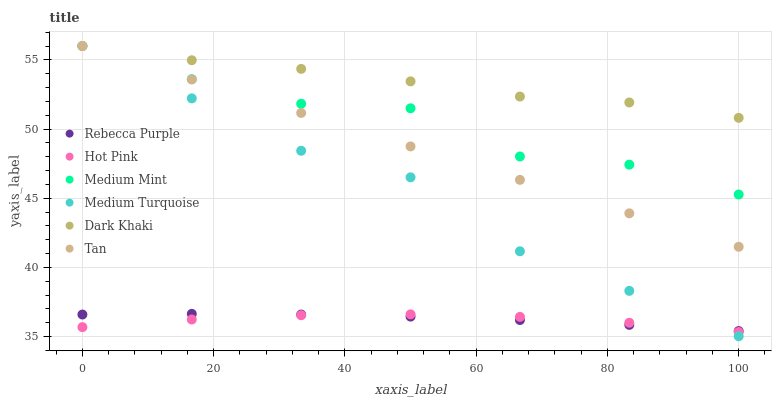Does Hot Pink have the minimum area under the curve?
Answer yes or no. Yes. Does Dark Khaki have the maximum area under the curve?
Answer yes or no. Yes. Does Dark Khaki have the minimum area under the curve?
Answer yes or no. No. Does Hot Pink have the maximum area under the curve?
Answer yes or no. No. Is Tan the smoothest?
Answer yes or no. Yes. Is Medium Mint the roughest?
Answer yes or no. Yes. Is Hot Pink the smoothest?
Answer yes or no. No. Is Hot Pink the roughest?
Answer yes or no. No. Does Medium Turquoise have the lowest value?
Answer yes or no. Yes. Does Hot Pink have the lowest value?
Answer yes or no. No. Does Tan have the highest value?
Answer yes or no. Yes. Does Hot Pink have the highest value?
Answer yes or no. No. Is Rebecca Purple less than Dark Khaki?
Answer yes or no. Yes. Is Tan greater than Hot Pink?
Answer yes or no. Yes. Does Medium Mint intersect Medium Turquoise?
Answer yes or no. Yes. Is Medium Mint less than Medium Turquoise?
Answer yes or no. No. Is Medium Mint greater than Medium Turquoise?
Answer yes or no. No. Does Rebecca Purple intersect Dark Khaki?
Answer yes or no. No. 